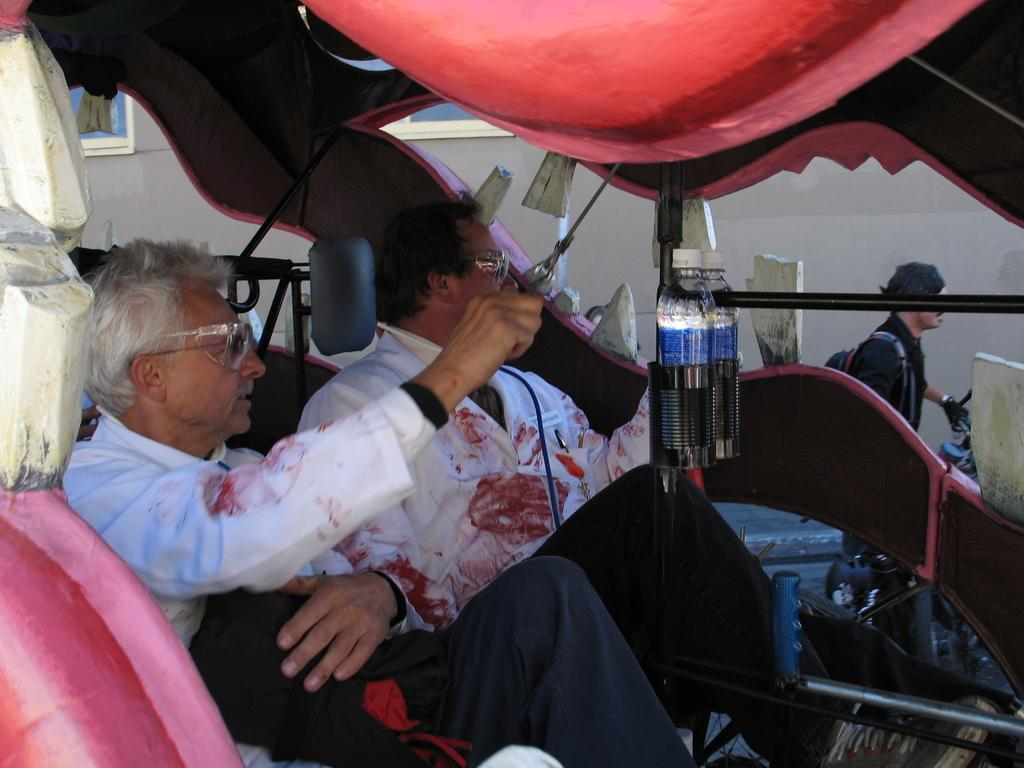How many people are in the vehicle in the image? There are two persons in the vehicle. What can be seen in the holder inside the vehicle? There are bottles in the holder. What structures are visible in the image? There are poles and a wall visible in the image. What is happening outside the vehicle in the image? There is a person on the road. What type of government is depicted in the image? There is no depiction of a government in the image. How many balls are visible in the image? There are no balls present in the image. 